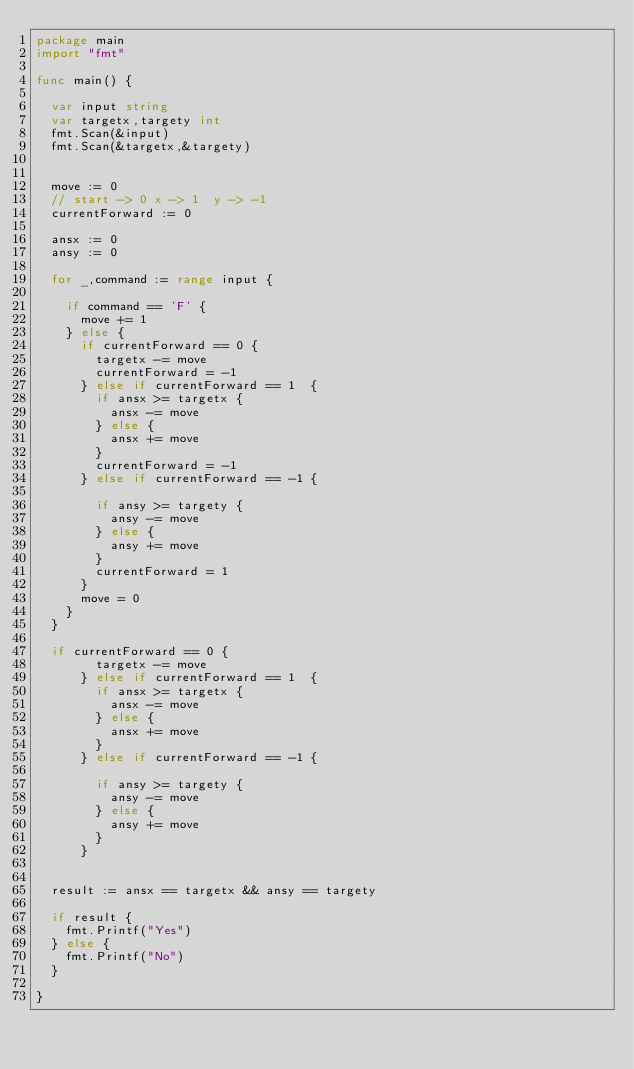<code> <loc_0><loc_0><loc_500><loc_500><_Go_>package main
import "fmt"

func main() {

  var input string
  var targetx,targety int
  fmt.Scan(&input)
  fmt.Scan(&targetx,&targety)
  
  
  move := 0
  // start -> 0 x -> 1  y -> -1
  currentForward := 0
  
  ansx := 0
  ansy := 0
  
  for _,command := range input {
  
    if command == 'F' {
      move += 1
    } else {
      if currentForward == 0 {
        targetx -= move 
        currentForward = -1
      } else if currentForward == 1  {
        if ansx >= targetx {
          ansx -= move
        } else {
          ansx += move
        }
        currentForward = -1
      } else if currentForward == -1 {
      
        if ansy >= targety {
          ansy -= move
        } else {
          ansy += move
        }
        currentForward = 1
      }
      move = 0
    }
  }
  
  if currentForward == 0 {
        targetx -= move 
      } else if currentForward == 1  {
        if ansx >= targetx {
          ansx -= move
        } else {
          ansx += move
        }
      } else if currentForward == -1 {
      
        if ansy >= targety {
          ansy -= move
        } else {
          ansy += move
        }
      }
  
  
  result := ansx == targetx && ansy == targety
  
  if result {
    fmt.Printf("Yes")
  } else {
    fmt.Printf("No")
  }
  
}
</code> 